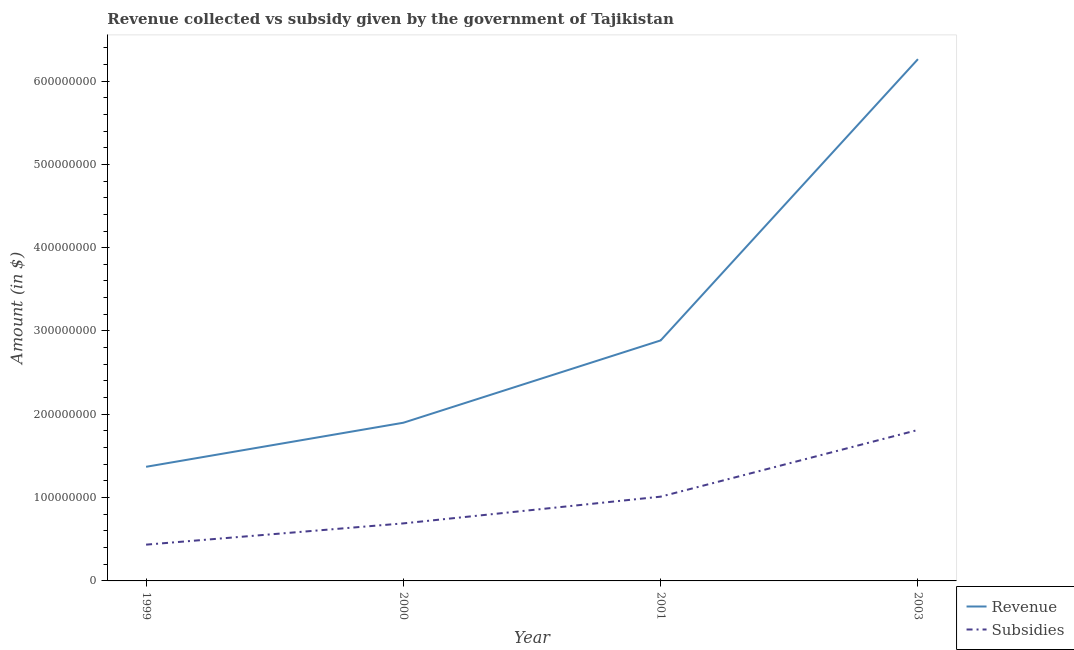How many different coloured lines are there?
Give a very brief answer. 2. Does the line corresponding to amount of revenue collected intersect with the line corresponding to amount of subsidies given?
Your response must be concise. No. What is the amount of subsidies given in 2001?
Your answer should be compact. 1.01e+08. Across all years, what is the maximum amount of subsidies given?
Keep it short and to the point. 1.81e+08. Across all years, what is the minimum amount of revenue collected?
Provide a succinct answer. 1.37e+08. In which year was the amount of subsidies given maximum?
Provide a short and direct response. 2003. What is the total amount of revenue collected in the graph?
Make the answer very short. 1.24e+09. What is the difference between the amount of subsidies given in 2000 and that in 2001?
Make the answer very short. -3.21e+07. What is the difference between the amount of subsidies given in 2003 and the amount of revenue collected in 2000?
Your answer should be compact. -8.67e+06. What is the average amount of subsidies given per year?
Your response must be concise. 9.87e+07. In the year 2000, what is the difference between the amount of subsidies given and amount of revenue collected?
Give a very brief answer. -1.21e+08. In how many years, is the amount of subsidies given greater than 600000000 $?
Provide a succinct answer. 0. What is the ratio of the amount of subsidies given in 2000 to that in 2001?
Provide a short and direct response. 0.68. Is the amount of subsidies given in 1999 less than that in 2001?
Provide a succinct answer. Yes. What is the difference between the highest and the second highest amount of subsidies given?
Offer a very short reply. 8.01e+07. What is the difference between the highest and the lowest amount of subsidies given?
Provide a short and direct response. 1.38e+08. In how many years, is the amount of revenue collected greater than the average amount of revenue collected taken over all years?
Provide a short and direct response. 1. How many lines are there?
Provide a succinct answer. 2. Are the values on the major ticks of Y-axis written in scientific E-notation?
Give a very brief answer. No. Does the graph contain any zero values?
Provide a succinct answer. No. Does the graph contain grids?
Your answer should be compact. No. How many legend labels are there?
Your answer should be very brief. 2. What is the title of the graph?
Provide a succinct answer. Revenue collected vs subsidy given by the government of Tajikistan. What is the label or title of the X-axis?
Offer a very short reply. Year. What is the label or title of the Y-axis?
Your answer should be compact. Amount (in $). What is the Amount (in $) in Revenue in 1999?
Provide a short and direct response. 1.37e+08. What is the Amount (in $) of Subsidies in 1999?
Ensure brevity in your answer.  4.35e+07. What is the Amount (in $) of Revenue in 2000?
Provide a succinct answer. 1.90e+08. What is the Amount (in $) in Subsidies in 2000?
Give a very brief answer. 6.91e+07. What is the Amount (in $) in Revenue in 2001?
Your response must be concise. 2.89e+08. What is the Amount (in $) in Subsidies in 2001?
Ensure brevity in your answer.  1.01e+08. What is the Amount (in $) of Revenue in 2003?
Your response must be concise. 6.26e+08. What is the Amount (in $) in Subsidies in 2003?
Your answer should be very brief. 1.81e+08. Across all years, what is the maximum Amount (in $) in Revenue?
Your answer should be compact. 6.26e+08. Across all years, what is the maximum Amount (in $) of Subsidies?
Your answer should be very brief. 1.81e+08. Across all years, what is the minimum Amount (in $) in Revenue?
Ensure brevity in your answer.  1.37e+08. Across all years, what is the minimum Amount (in $) in Subsidies?
Provide a short and direct response. 4.35e+07. What is the total Amount (in $) of Revenue in the graph?
Your answer should be very brief. 1.24e+09. What is the total Amount (in $) in Subsidies in the graph?
Keep it short and to the point. 3.95e+08. What is the difference between the Amount (in $) in Revenue in 1999 and that in 2000?
Make the answer very short. -5.29e+07. What is the difference between the Amount (in $) in Subsidies in 1999 and that in 2000?
Your answer should be compact. -2.55e+07. What is the difference between the Amount (in $) of Revenue in 1999 and that in 2001?
Offer a very short reply. -1.52e+08. What is the difference between the Amount (in $) of Subsidies in 1999 and that in 2001?
Make the answer very short. -5.76e+07. What is the difference between the Amount (in $) in Revenue in 1999 and that in 2003?
Ensure brevity in your answer.  -4.89e+08. What is the difference between the Amount (in $) in Subsidies in 1999 and that in 2003?
Offer a very short reply. -1.38e+08. What is the difference between the Amount (in $) of Revenue in 2000 and that in 2001?
Keep it short and to the point. -9.88e+07. What is the difference between the Amount (in $) of Subsidies in 2000 and that in 2001?
Your answer should be compact. -3.21e+07. What is the difference between the Amount (in $) in Revenue in 2000 and that in 2003?
Ensure brevity in your answer.  -4.36e+08. What is the difference between the Amount (in $) of Subsidies in 2000 and that in 2003?
Make the answer very short. -1.12e+08. What is the difference between the Amount (in $) of Revenue in 2001 and that in 2003?
Provide a succinct answer. -3.38e+08. What is the difference between the Amount (in $) in Subsidies in 2001 and that in 2003?
Ensure brevity in your answer.  -8.01e+07. What is the difference between the Amount (in $) in Revenue in 1999 and the Amount (in $) in Subsidies in 2000?
Give a very brief answer. 6.79e+07. What is the difference between the Amount (in $) of Revenue in 1999 and the Amount (in $) of Subsidies in 2001?
Your response must be concise. 3.58e+07. What is the difference between the Amount (in $) of Revenue in 1999 and the Amount (in $) of Subsidies in 2003?
Ensure brevity in your answer.  -4.42e+07. What is the difference between the Amount (in $) of Revenue in 2000 and the Amount (in $) of Subsidies in 2001?
Your answer should be very brief. 8.87e+07. What is the difference between the Amount (in $) of Revenue in 2000 and the Amount (in $) of Subsidies in 2003?
Ensure brevity in your answer.  8.67e+06. What is the difference between the Amount (in $) of Revenue in 2001 and the Amount (in $) of Subsidies in 2003?
Provide a succinct answer. 1.07e+08. What is the average Amount (in $) of Revenue per year?
Offer a terse response. 3.10e+08. What is the average Amount (in $) in Subsidies per year?
Your answer should be compact. 9.87e+07. In the year 1999, what is the difference between the Amount (in $) of Revenue and Amount (in $) of Subsidies?
Your answer should be compact. 9.35e+07. In the year 2000, what is the difference between the Amount (in $) of Revenue and Amount (in $) of Subsidies?
Provide a succinct answer. 1.21e+08. In the year 2001, what is the difference between the Amount (in $) in Revenue and Amount (in $) in Subsidies?
Offer a very short reply. 1.88e+08. In the year 2003, what is the difference between the Amount (in $) in Revenue and Amount (in $) in Subsidies?
Offer a very short reply. 4.45e+08. What is the ratio of the Amount (in $) of Revenue in 1999 to that in 2000?
Provide a succinct answer. 0.72. What is the ratio of the Amount (in $) of Subsidies in 1999 to that in 2000?
Make the answer very short. 0.63. What is the ratio of the Amount (in $) of Revenue in 1999 to that in 2001?
Your response must be concise. 0.47. What is the ratio of the Amount (in $) in Subsidies in 1999 to that in 2001?
Keep it short and to the point. 0.43. What is the ratio of the Amount (in $) of Revenue in 1999 to that in 2003?
Give a very brief answer. 0.22. What is the ratio of the Amount (in $) in Subsidies in 1999 to that in 2003?
Your response must be concise. 0.24. What is the ratio of the Amount (in $) of Revenue in 2000 to that in 2001?
Provide a succinct answer. 0.66. What is the ratio of the Amount (in $) in Subsidies in 2000 to that in 2001?
Your response must be concise. 0.68. What is the ratio of the Amount (in $) of Revenue in 2000 to that in 2003?
Offer a very short reply. 0.3. What is the ratio of the Amount (in $) in Subsidies in 2000 to that in 2003?
Give a very brief answer. 0.38. What is the ratio of the Amount (in $) in Revenue in 2001 to that in 2003?
Offer a terse response. 0.46. What is the ratio of the Amount (in $) in Subsidies in 2001 to that in 2003?
Ensure brevity in your answer.  0.56. What is the difference between the highest and the second highest Amount (in $) of Revenue?
Your answer should be very brief. 3.38e+08. What is the difference between the highest and the second highest Amount (in $) of Subsidies?
Make the answer very short. 8.01e+07. What is the difference between the highest and the lowest Amount (in $) in Revenue?
Make the answer very short. 4.89e+08. What is the difference between the highest and the lowest Amount (in $) in Subsidies?
Your response must be concise. 1.38e+08. 